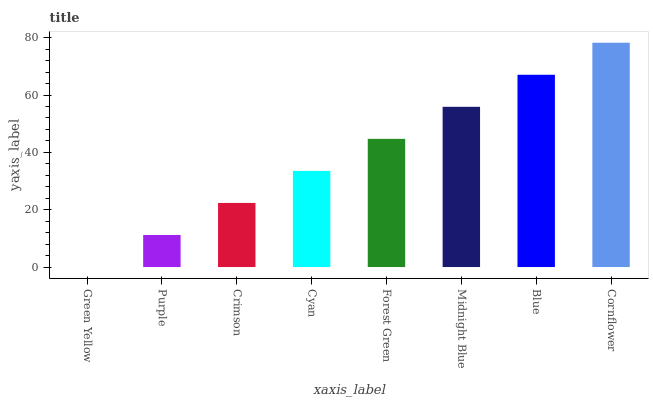Is Purple the minimum?
Answer yes or no. No. Is Purple the maximum?
Answer yes or no. No. Is Purple greater than Green Yellow?
Answer yes or no. Yes. Is Green Yellow less than Purple?
Answer yes or no. Yes. Is Green Yellow greater than Purple?
Answer yes or no. No. Is Purple less than Green Yellow?
Answer yes or no. No. Is Forest Green the high median?
Answer yes or no. Yes. Is Cyan the low median?
Answer yes or no. Yes. Is Midnight Blue the high median?
Answer yes or no. No. Is Purple the low median?
Answer yes or no. No. 